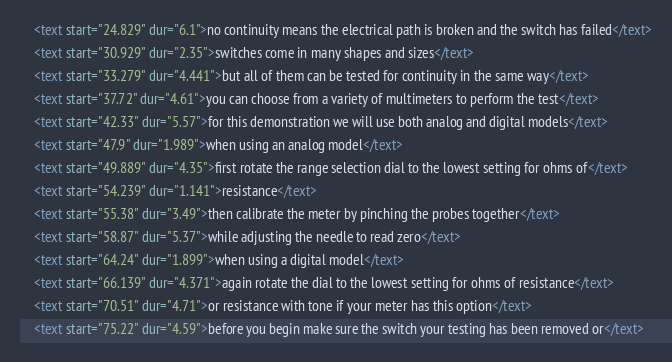Convert code to text. <code><loc_0><loc_0><loc_500><loc_500><_XML_>    <text start="24.829" dur="6.1">no continuity means the electrical path is broken and the switch has failed</text>
    <text start="30.929" dur="2.35">switches come in many shapes and sizes</text>
    <text start="33.279" dur="4.441">but all of them can be tested for continuity in the same way</text>
    <text start="37.72" dur="4.61">you can choose from a variety of multimeters to perform the test</text>
    <text start="42.33" dur="5.57">for this demonstration we will use both analog and digital models</text>
    <text start="47.9" dur="1.989">when using an analog model</text>
    <text start="49.889" dur="4.35">first rotate the range selection dial to the lowest setting for ohms of</text>
    <text start="54.239" dur="1.141">resistance</text>
    <text start="55.38" dur="3.49">then calibrate the meter by pinching the probes together</text>
    <text start="58.87" dur="5.37">while adjusting the needle to read zero</text>
    <text start="64.24" dur="1.899">when using a digital model</text>
    <text start="66.139" dur="4.371">again rotate the dial to the lowest setting for ohms of resistance</text>
    <text start="70.51" dur="4.71">or resistance with tone if your meter has this option</text>
    <text start="75.22" dur="4.59">before you begin make sure the switch your testing has been removed or</text></code> 